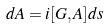Convert formula to latex. <formula><loc_0><loc_0><loc_500><loc_500>d A = i [ G , A ] d s</formula> 